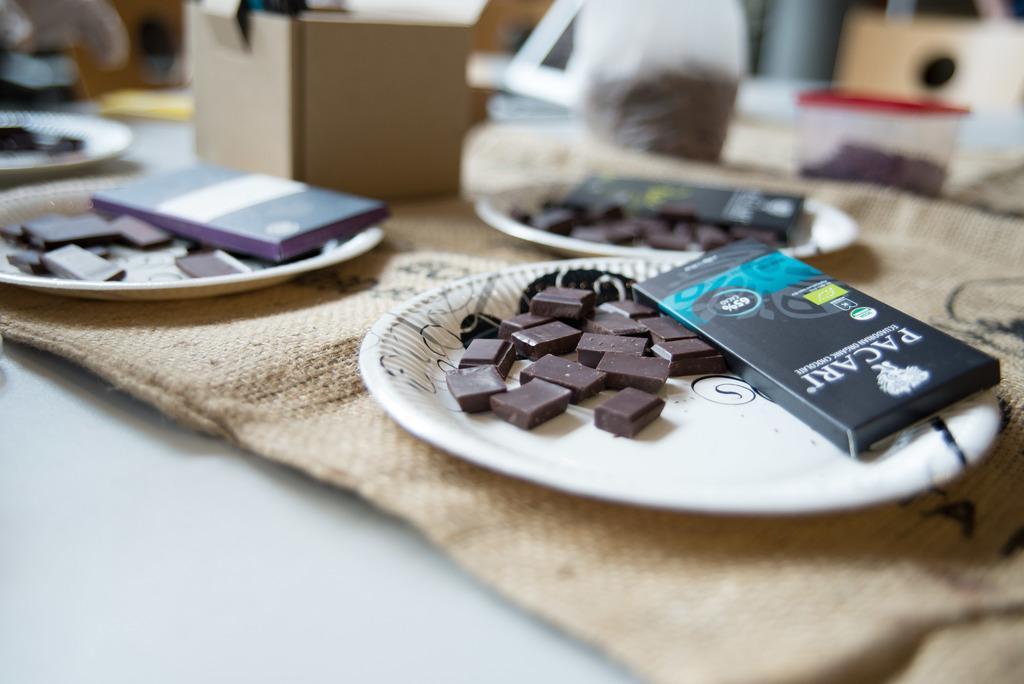Can you describe this image briefly? In this picture we can see chocolates and boxes in the plates, beside to the plates we can find few boxes and other things. 